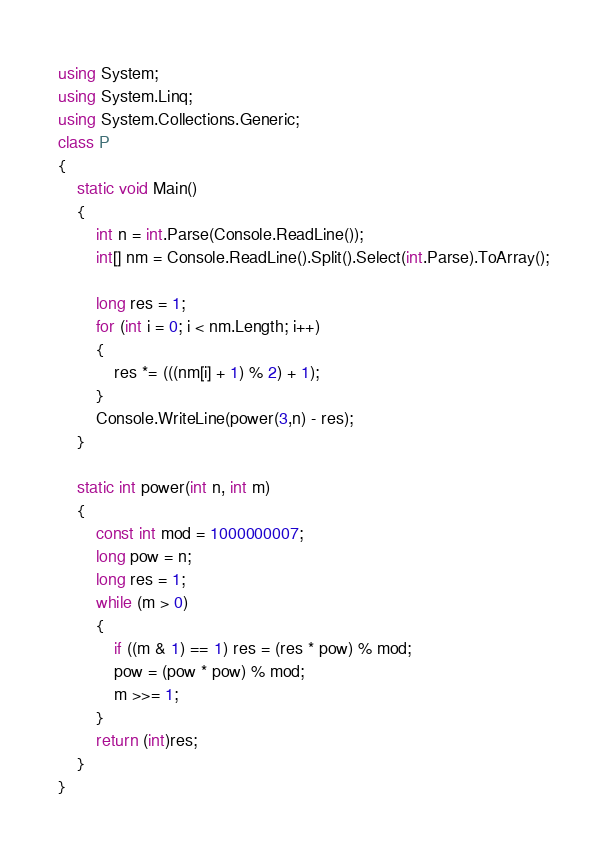<code> <loc_0><loc_0><loc_500><loc_500><_C#_>using System;
using System.Linq;
using System.Collections.Generic;
class P
{
    static void Main()
    {
        int n = int.Parse(Console.ReadLine());
        int[] nm = Console.ReadLine().Split().Select(int.Parse).ToArray();

        long res = 1;
        for (int i = 0; i < nm.Length; i++)
        {
            res *= (((nm[i] + 1) % 2) + 1);
        }
        Console.WriteLine(power(3,n) - res);
    }

    static int power(int n, int m)
    {
        const int mod = 1000000007;
        long pow = n;
        long res = 1;
        while (m > 0)
        {
            if ((m & 1) == 1) res = (res * pow) % mod;
            pow = (pow * pow) % mod;
            m >>= 1;
        }
        return (int)res;
    }
}
</code> 